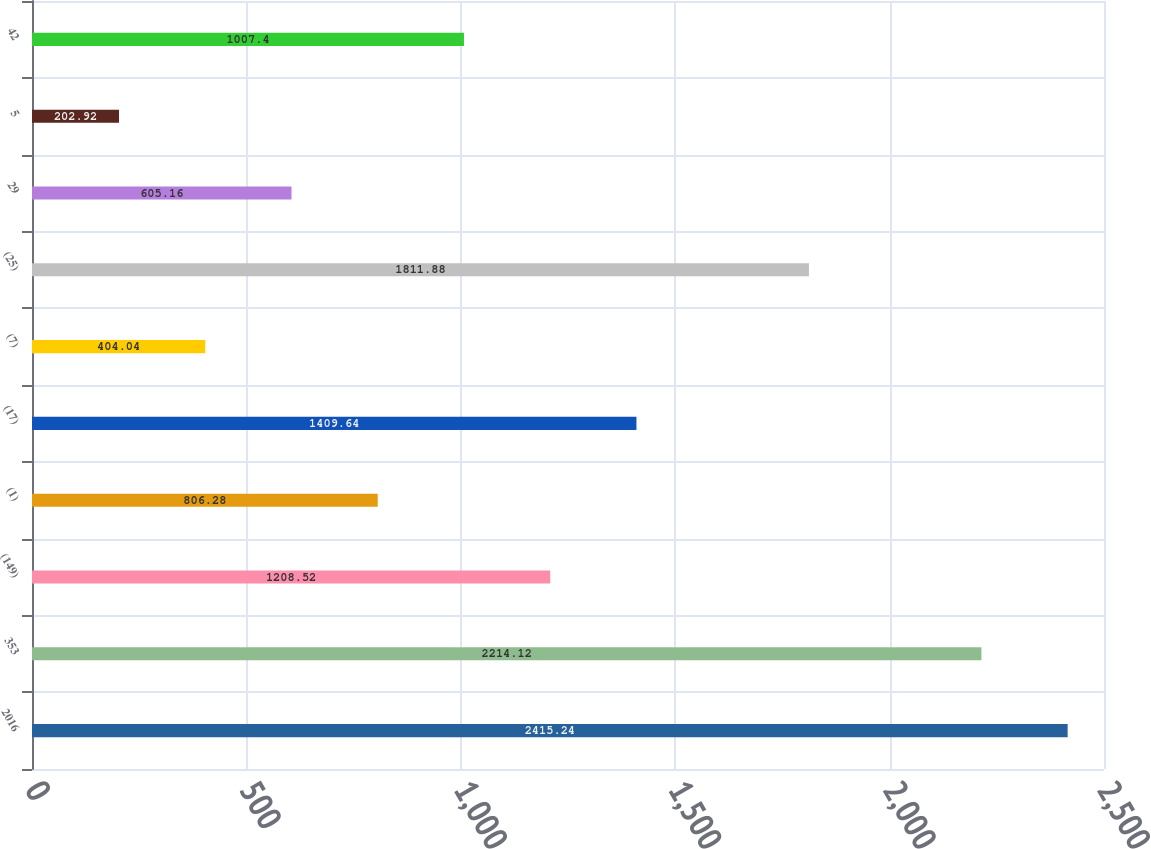Convert chart. <chart><loc_0><loc_0><loc_500><loc_500><bar_chart><fcel>2016<fcel>353<fcel>(149)<fcel>(1)<fcel>(17)<fcel>(7)<fcel>(25)<fcel>29<fcel>5<fcel>42<nl><fcel>2415.24<fcel>2214.12<fcel>1208.52<fcel>806.28<fcel>1409.64<fcel>404.04<fcel>1811.88<fcel>605.16<fcel>202.92<fcel>1007.4<nl></chart> 